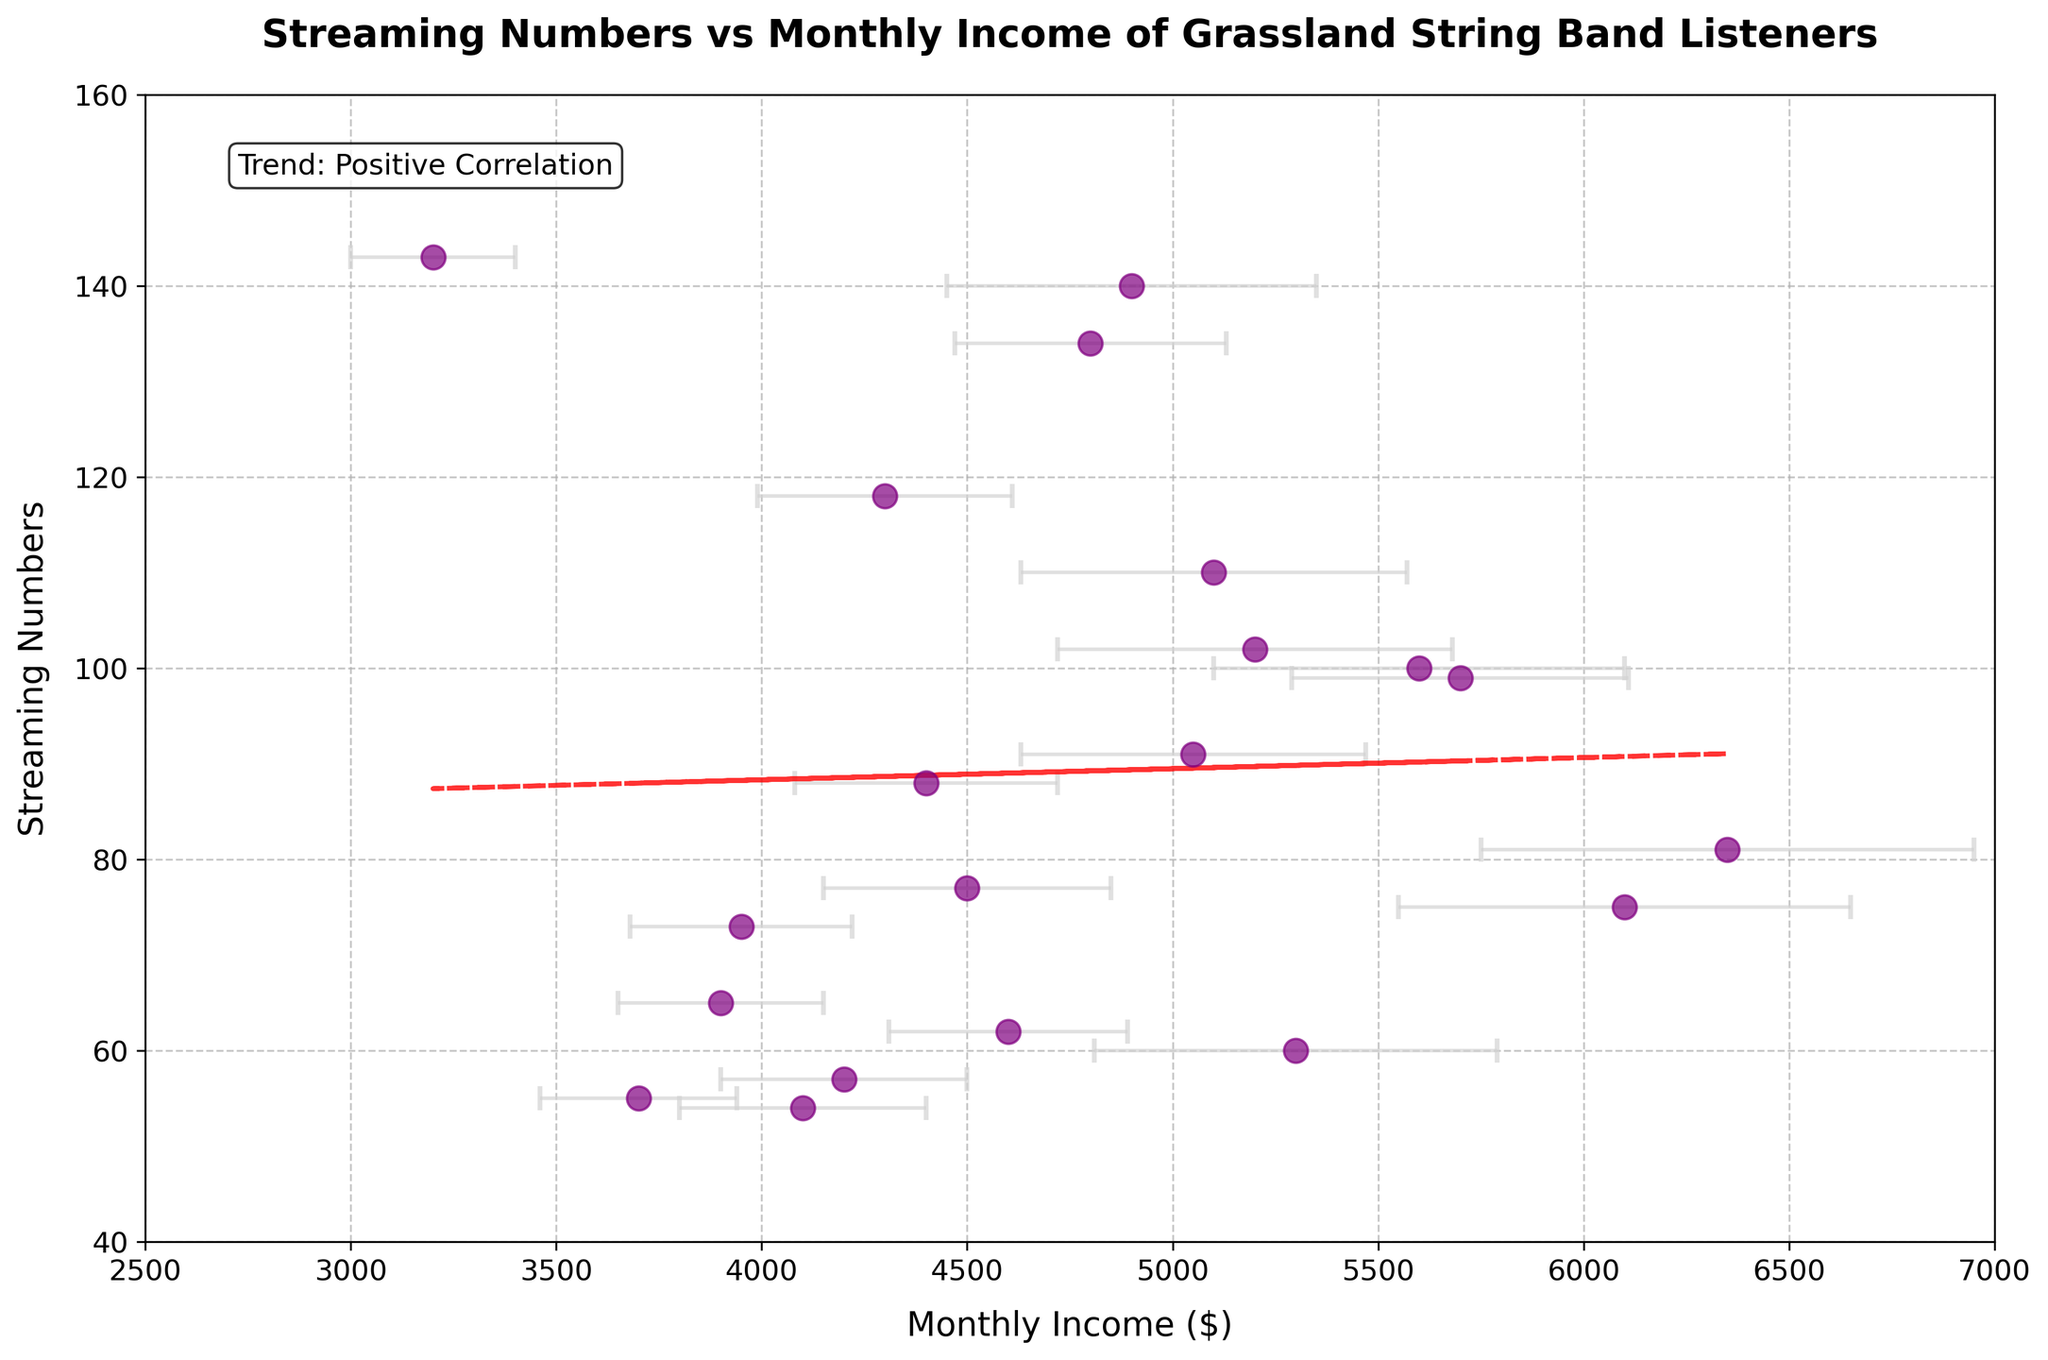What's the title of the figure? The title of the figure is displayed prominently at the top of the chart. It gives an overview of what the chart represents.
Answer: Streaming Numbers vs Monthly Income of Grassland String Band Listeners What do the x and y axes represent? The x-axis is labeled 'Monthly Income ($)' which shows the monthly income of Grassland String Band listeners. The y-axis is labeled 'Streaming Numbers' which shows the number of streamings per listener.
Answer: Monthly Income and Streaming Numbers What color are the data points in the scatter plot? The data points are colored to make them easily discernible and visually appealing. In this figure, the data points are purple.
Answer: Purple What do the error bars in the plot represent? Error bars represent the standard deviation of the monthly income, providing a sense of the variability or uncertainty in the data. They extend horizontally from each data point.
Answer: Standard deviation of monthly income Which listener has the highest streaming numbers and what is their monthly income? By looking at the scatter plot, the point that represents the highest streaming number determines the listener. The highest streaming number is 143 with a monthly income of 3200.
Answer: Listener 8 with a monthly income of 3200 What is the range of monthly incomes in the chart? The x-axis provides information on the spread of monthly incomes. The range is from the minimum to the maximum monthly income shown on the axis, from 2500 to 7000.
Answer: 2500 to 7000 How many listeners have streaming numbers greater than 100? Counting the points above the 100 streaming numbers on the y-axis reveals the number of listeners with higher streaming numbers.
Answer: 6 listeners Is there a positive or negative correlation between streaming numbers and monthly income? The trend line added to the scatter plot shows the general direction of the data. An upward trend indicates a positive correlation.
Answer: Positive correlation Which two listeners have the closest monthly incomes and what are those incomes? By visually comparing the positioning of points along the x-axis, the two listeners with the closest x-values can be identified. Listeners with incomes of 3950 and 3900 are the closest.
Answer: Listeners 5 and 16 with incomes of 3950 and 3900 What does the trend line in the plot indicate about the relationship between monthly income and streaming numbers? The trend line (fitted with a linear polynomial) shows the overall direction of the data points. Given the line slopes upwards, it indicates that higher monthly income tends to associate with higher streaming numbers.
Answer: Higher monthly income associates with higher streaming numbers 